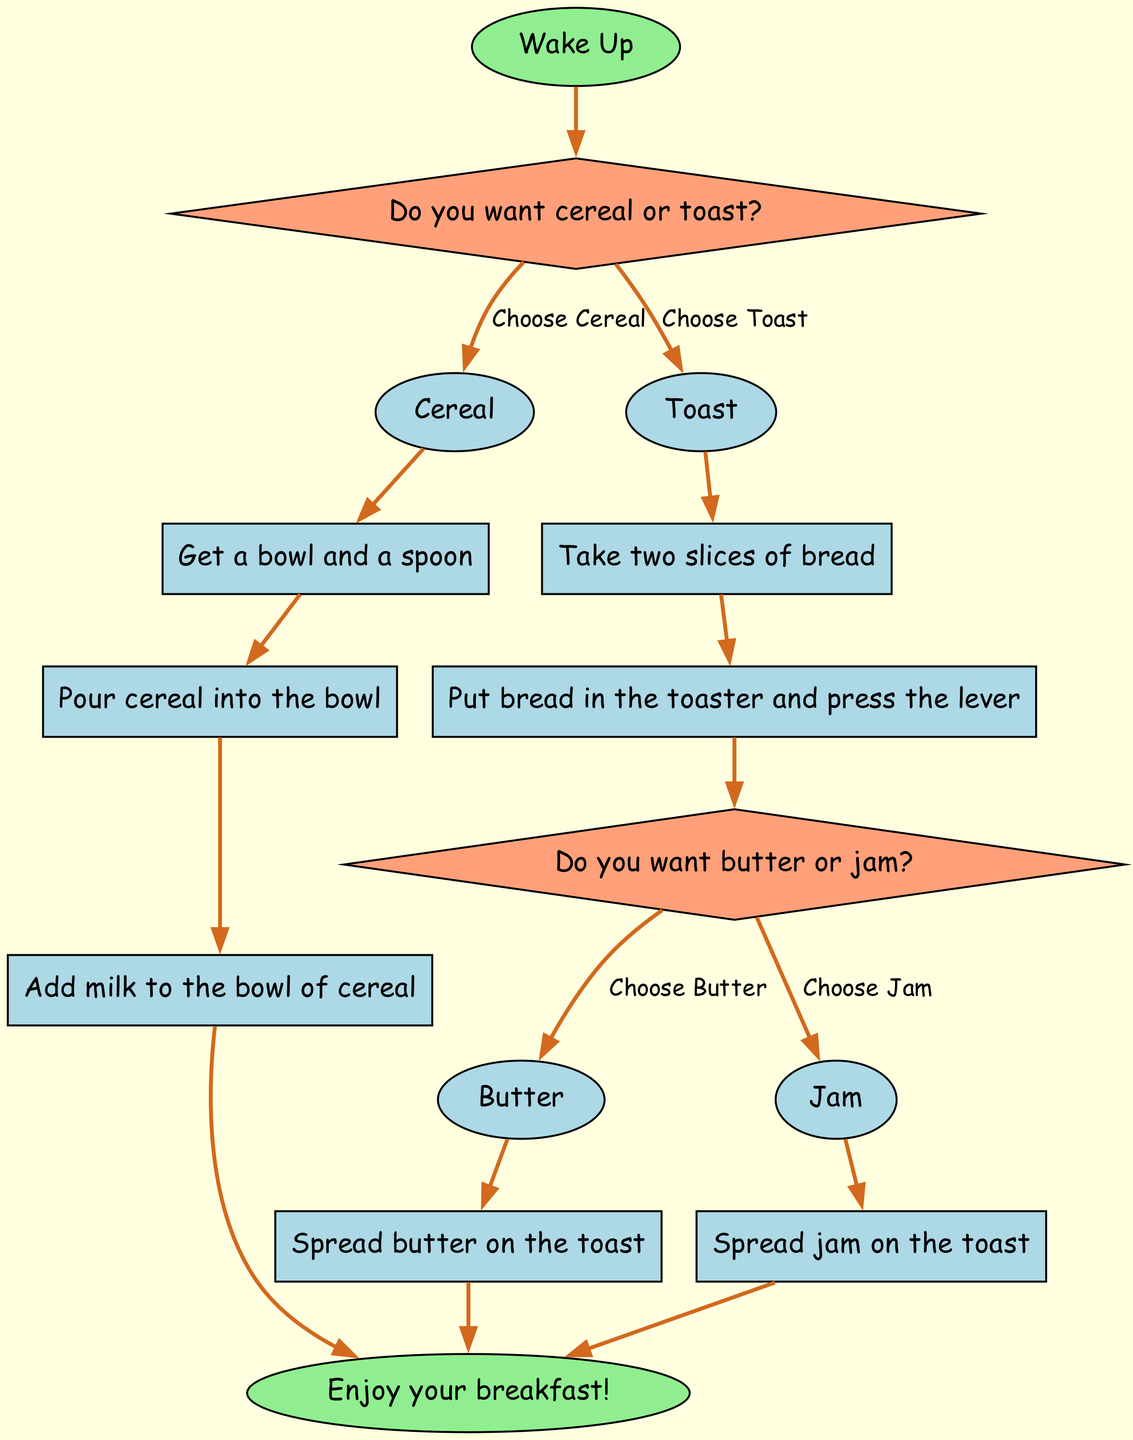What is the starting action in the flowchart? The flowchart starts with the action "Wake Up". This can be identified at the top of the diagram, which is the designated starting point.
Answer: Wake Up What do you need to decide between at the first decision point? The first decision point asks whether you want "cereal or toast". This is directly stated in the decision node that branches off from the start node.
Answer: cereal or toast What are the actions taken if you choose cereal? If cereal is chosen, the actions are: "Get a bowl and a spoon", then "Pour cereal into the bowl", and finally "Add milk to the bowl of cereal". These steps follow in sequence after choosing cereal.
Answer: Get a bowl and a spoon; Pour cereal into the bowl; Add milk to the bowl of cereal How many choices do you have to spread on toast? There are two choices for spreading on toast: "butter or jam". This decision point highlights the available toppings for the toast after it is prepared.
Answer: butter or jam What happens after spreading butter on the toast? After spreading butter on the toast, the final outcome leads to "Enjoy your breakfast!". This step shows the conclusion after completing the toast preparation process.
Answer: Enjoy your breakfast! What action follows the decision to put bread in the toaster? After placing the bread in the toaster and pressing the lever (the action after choosing toast), the next step is the decision point about whether to choose butter or jam. This follows from toast preparation.
Answer: Do you want butter or jam? What is the final output if you choose jam for your toast? If jam is chosen for your toast, the final output is "Enjoy your breakfast!". This follow-up occurs after the jam is spread on the toast, concluding the breakfast preparation.
Answer: Enjoy your breakfast! What type of decision point appears after selecting toast? After selecting toast, a decision point appears that asks whether you want "butter or jam". This is a branching decision point that follows the initial choice of toast.
Answer: butter or jam 